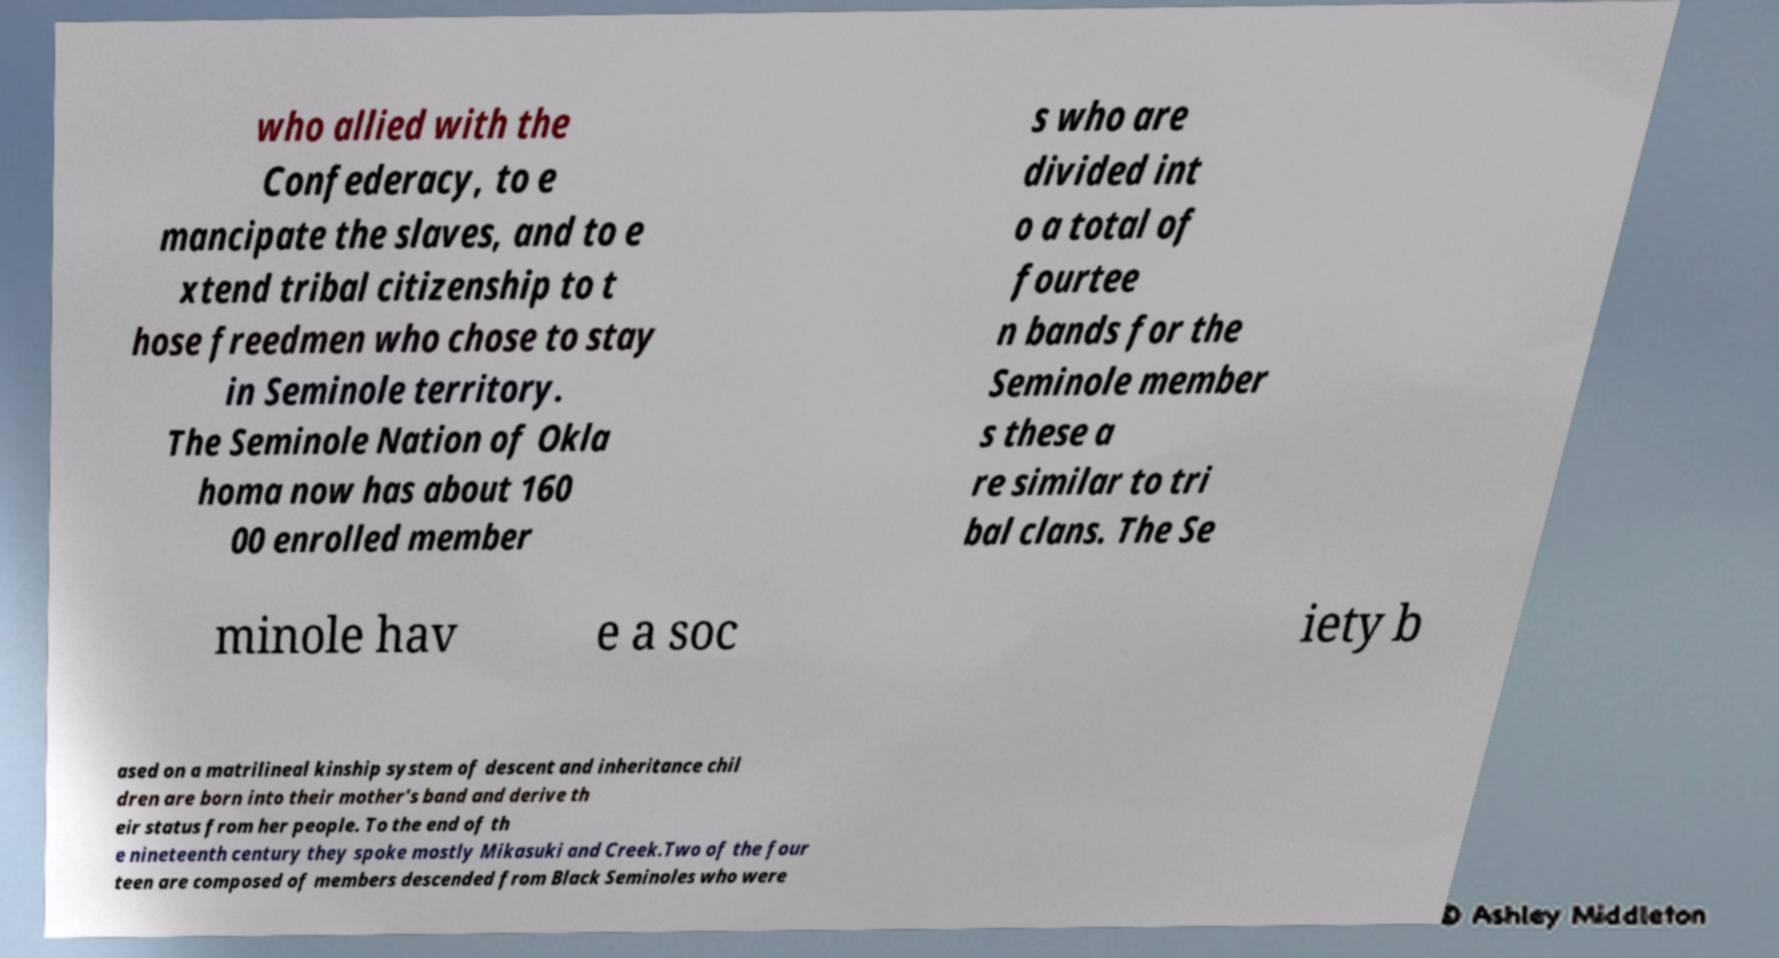Can you accurately transcribe the text from the provided image for me? who allied with the Confederacy, to e mancipate the slaves, and to e xtend tribal citizenship to t hose freedmen who chose to stay in Seminole territory. The Seminole Nation of Okla homa now has about 160 00 enrolled member s who are divided int o a total of fourtee n bands for the Seminole member s these a re similar to tri bal clans. The Se minole hav e a soc iety b ased on a matrilineal kinship system of descent and inheritance chil dren are born into their mother's band and derive th eir status from her people. To the end of th e nineteenth century they spoke mostly Mikasuki and Creek.Two of the four teen are composed of members descended from Black Seminoles who were 